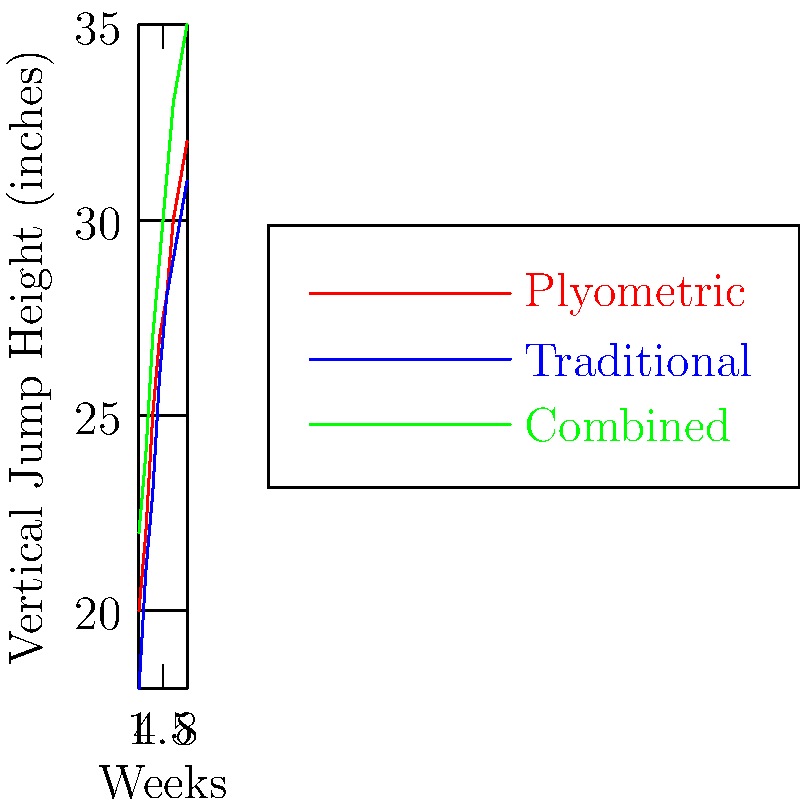As a basketball coach analyzing different training regimens, you come across this scatter plot showing the impact of three training methods on vertical jump height over an 8-week period. Which training method shows the highest overall improvement in vertical jump height, and what is the approximate difference in improvement between this method and the least effective method after 8 weeks? To answer this question, we need to follow these steps:

1. Identify the three training methods:
   - Red line: Plyometric training
   - Blue line: Traditional training
   - Green line: Combined training

2. Determine the starting and ending points for each method:
   - Plyometric: Start ≈ 20 inches, End ≈ 32 inches
   - Traditional: Start ≈ 18 inches, End ≈ 31 inches
   - Combined: Start ≈ 22 inches, End ≈ 35 inches

3. Calculate the improvement for each method:
   - Plyometric: 32 - 20 = 12 inches
   - Traditional: 31 - 18 = 13 inches
   - Combined: 35 - 22 = 13 inches

4. Identify the method with the highest overall improvement:
   Both Traditional and Combined methods show a 13-inch improvement, which is higher than the Plyometric method's 12-inch improvement. However, the Combined method ends at a higher overall jump height (35 inches vs. 31 inches for Traditional), so we consider it the most effective.

5. Identify the least effective method:
   The Plyometric method shows the least improvement at 12 inches.

6. Calculate the difference between the most and least effective methods:
   Combined (most effective) improvement: 13 inches
   Plyometric (least effective) improvement: 12 inches
   Difference: 13 - 12 = 1 inch

Therefore, the Combined training method shows the highest overall improvement, and the difference in improvement between the Combined method and the Plyometric method (least effective) after 8 weeks is approximately 1 inch.
Answer: Combined method; 1 inch difference 